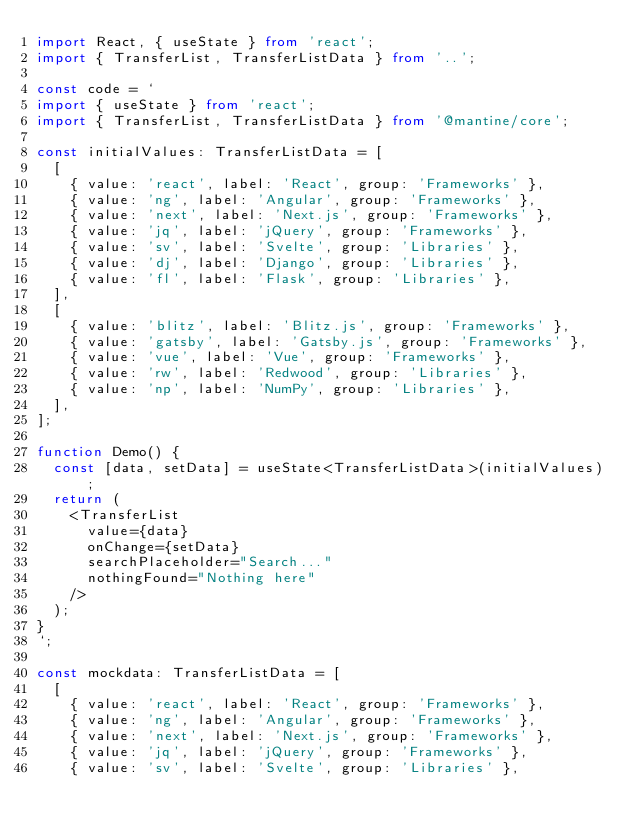<code> <loc_0><loc_0><loc_500><loc_500><_TypeScript_>import React, { useState } from 'react';
import { TransferList, TransferListData } from '..';

const code = `
import { useState } from 'react';
import { TransferList, TransferListData } from '@mantine/core';

const initialValues: TransferListData = [
  [
    { value: 'react', label: 'React', group: 'Frameworks' },
    { value: 'ng', label: 'Angular', group: 'Frameworks' },
    { value: 'next', label: 'Next.js', group: 'Frameworks' },
    { value: 'jq', label: 'jQuery', group: 'Frameworks' },
    { value: 'sv', label: 'Svelte', group: 'Libraries' },
    { value: 'dj', label: 'Django', group: 'Libraries' },
    { value: 'fl', label: 'Flask', group: 'Libraries' },
  ],
  [
    { value: 'blitz', label: 'Blitz.js', group: 'Frameworks' },
    { value: 'gatsby', label: 'Gatsby.js', group: 'Frameworks' },
    { value: 'vue', label: 'Vue', group: 'Frameworks' },
    { value: 'rw', label: 'Redwood', group: 'Libraries' },
    { value: 'np', label: 'NumPy', group: 'Libraries' },
  ],
];

function Demo() {
  const [data, setData] = useState<TransferListData>(initialValues);
  return (
    <TransferList
      value={data}
      onChange={setData}
      searchPlaceholder="Search..."
      nothingFound="Nothing here"
    />
  );
}
`;

const mockdata: TransferListData = [
  [
    { value: 'react', label: 'React', group: 'Frameworks' },
    { value: 'ng', label: 'Angular', group: 'Frameworks' },
    { value: 'next', label: 'Next.js', group: 'Frameworks' },
    { value: 'jq', label: 'jQuery', group: 'Frameworks' },
    { value: 'sv', label: 'Svelte', group: 'Libraries' },</code> 